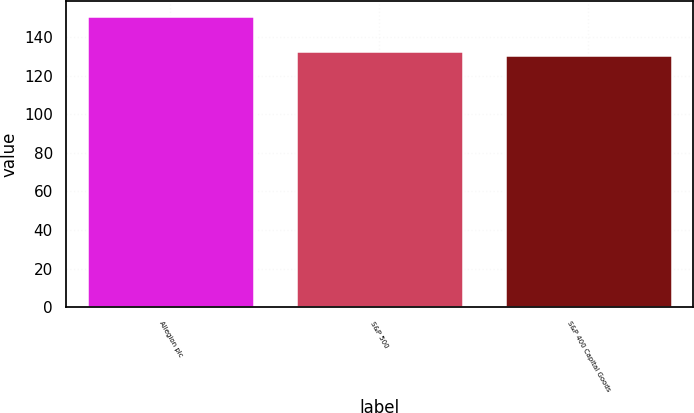Convert chart to OTSL. <chart><loc_0><loc_0><loc_500><loc_500><bar_chart><fcel>Allegion plc<fcel>S&P 500<fcel>S&P 400 Capital Goods<nl><fcel>150.97<fcel>132.73<fcel>130.7<nl></chart> 